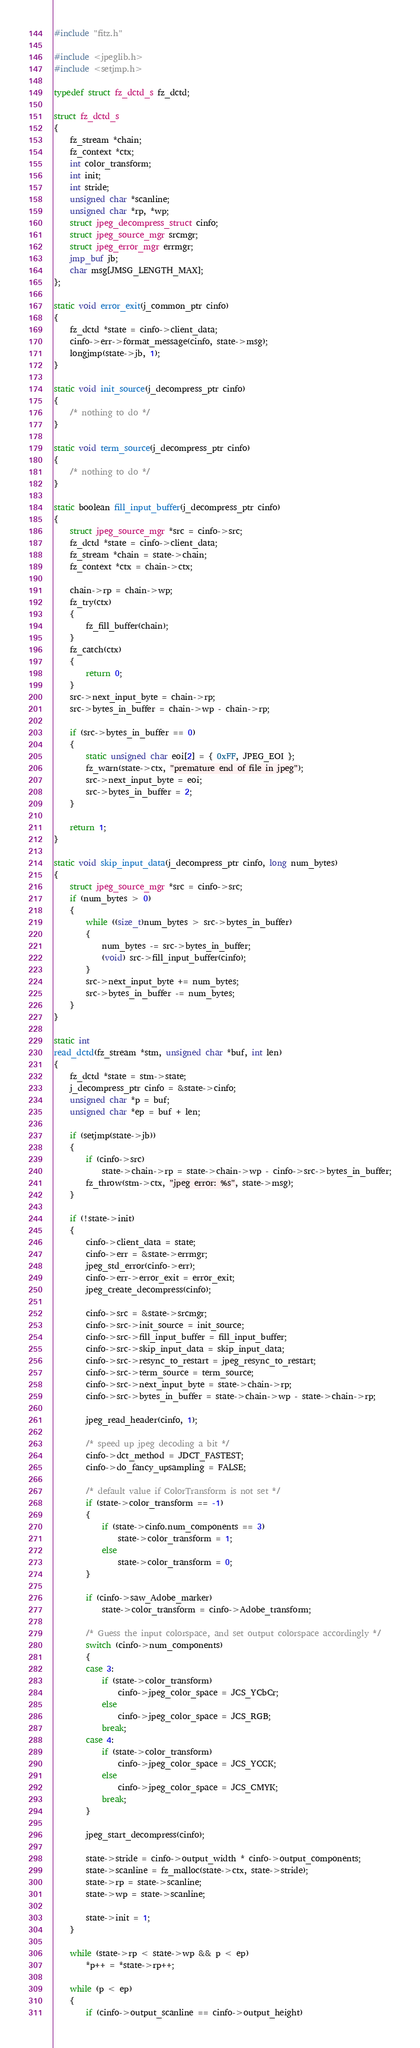Convert code to text. <code><loc_0><loc_0><loc_500><loc_500><_C_>#include "fitz.h"

#include <jpeglib.h>
#include <setjmp.h>

typedef struct fz_dctd_s fz_dctd;

struct fz_dctd_s
{
	fz_stream *chain;
	fz_context *ctx;
	int color_transform;
	int init;
	int stride;
	unsigned char *scanline;
	unsigned char *rp, *wp;
	struct jpeg_decompress_struct cinfo;
	struct jpeg_source_mgr srcmgr;
	struct jpeg_error_mgr errmgr;
	jmp_buf jb;
	char msg[JMSG_LENGTH_MAX];
};

static void error_exit(j_common_ptr cinfo)
{
	fz_dctd *state = cinfo->client_data;
	cinfo->err->format_message(cinfo, state->msg);
	longjmp(state->jb, 1);
}

static void init_source(j_decompress_ptr cinfo)
{
	/* nothing to do */
}

static void term_source(j_decompress_ptr cinfo)
{
	/* nothing to do */
}

static boolean fill_input_buffer(j_decompress_ptr cinfo)
{
	struct jpeg_source_mgr *src = cinfo->src;
	fz_dctd *state = cinfo->client_data;
	fz_stream *chain = state->chain;
	fz_context *ctx = chain->ctx;

	chain->rp = chain->wp;
	fz_try(ctx)
	{
		fz_fill_buffer(chain);
	}
	fz_catch(ctx)
	{
		return 0;
	}
	src->next_input_byte = chain->rp;
	src->bytes_in_buffer = chain->wp - chain->rp;

	if (src->bytes_in_buffer == 0)
	{
		static unsigned char eoi[2] = { 0xFF, JPEG_EOI };
		fz_warn(state->ctx, "premature end of file in jpeg");
		src->next_input_byte = eoi;
		src->bytes_in_buffer = 2;
	}

	return 1;
}

static void skip_input_data(j_decompress_ptr cinfo, long num_bytes)
{
	struct jpeg_source_mgr *src = cinfo->src;
	if (num_bytes > 0)
	{
		while ((size_t)num_bytes > src->bytes_in_buffer)
		{
			num_bytes -= src->bytes_in_buffer;
			(void) src->fill_input_buffer(cinfo);
		}
		src->next_input_byte += num_bytes;
		src->bytes_in_buffer -= num_bytes;
	}
}

static int
read_dctd(fz_stream *stm, unsigned char *buf, int len)
{
	fz_dctd *state = stm->state;
	j_decompress_ptr cinfo = &state->cinfo;
	unsigned char *p = buf;
	unsigned char *ep = buf + len;

	if (setjmp(state->jb))
	{
		if (cinfo->src)
			state->chain->rp = state->chain->wp - cinfo->src->bytes_in_buffer;
		fz_throw(stm->ctx, "jpeg error: %s", state->msg);
	}

	if (!state->init)
	{
		cinfo->client_data = state;
		cinfo->err = &state->errmgr;
		jpeg_std_error(cinfo->err);
		cinfo->err->error_exit = error_exit;
		jpeg_create_decompress(cinfo);

		cinfo->src = &state->srcmgr;
		cinfo->src->init_source = init_source;
		cinfo->src->fill_input_buffer = fill_input_buffer;
		cinfo->src->skip_input_data = skip_input_data;
		cinfo->src->resync_to_restart = jpeg_resync_to_restart;
		cinfo->src->term_source = term_source;
		cinfo->src->next_input_byte = state->chain->rp;
		cinfo->src->bytes_in_buffer = state->chain->wp - state->chain->rp;

		jpeg_read_header(cinfo, 1);

		/* speed up jpeg decoding a bit */
		cinfo->dct_method = JDCT_FASTEST;
		cinfo->do_fancy_upsampling = FALSE;

		/* default value if ColorTransform is not set */
		if (state->color_transform == -1)
		{
			if (state->cinfo.num_components == 3)
				state->color_transform = 1;
			else
				state->color_transform = 0;
		}

		if (cinfo->saw_Adobe_marker)
			state->color_transform = cinfo->Adobe_transform;

		/* Guess the input colorspace, and set output colorspace accordingly */
		switch (cinfo->num_components)
		{
		case 3:
			if (state->color_transform)
				cinfo->jpeg_color_space = JCS_YCbCr;
			else
				cinfo->jpeg_color_space = JCS_RGB;
			break;
		case 4:
			if (state->color_transform)
				cinfo->jpeg_color_space = JCS_YCCK;
			else
				cinfo->jpeg_color_space = JCS_CMYK;
			break;
		}

		jpeg_start_decompress(cinfo);

		state->stride = cinfo->output_width * cinfo->output_components;
		state->scanline = fz_malloc(state->ctx, state->stride);
		state->rp = state->scanline;
		state->wp = state->scanline;

		state->init = 1;
	}

	while (state->rp < state->wp && p < ep)
		*p++ = *state->rp++;

	while (p < ep)
	{
		if (cinfo->output_scanline == cinfo->output_height)</code> 